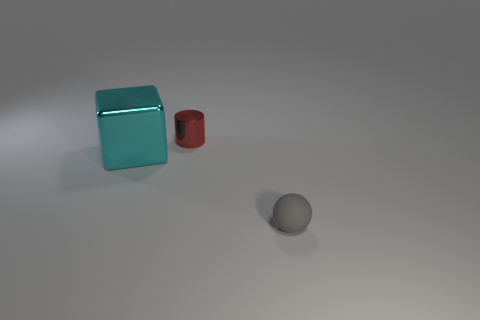Are there any other things that have the same material as the ball?
Your response must be concise. No. There is a metal object to the right of the big metal object; does it have the same size as the object that is in front of the shiny cube?
Your answer should be compact. Yes. Do the gray thing and the cyan metal thing have the same shape?
Your response must be concise. No. How many other green blocks have the same material as the large cube?
Give a very brief answer. 0. What number of objects are either metal cubes or tiny cyan rubber spheres?
Your answer should be compact. 1. Are there any large metallic objects that are to the right of the small thing on the left side of the gray thing?
Keep it short and to the point. No. Is the number of tiny gray things in front of the small gray rubber sphere greater than the number of cyan objects in front of the small red cylinder?
Your response must be concise. No. How many small metal objects are the same color as the large metallic object?
Ensure brevity in your answer.  0. Is the color of the small thing that is to the left of the gray ball the same as the tiny thing right of the tiny red cylinder?
Your response must be concise. No. Are there any large metal blocks behind the red cylinder?
Provide a short and direct response. No. 